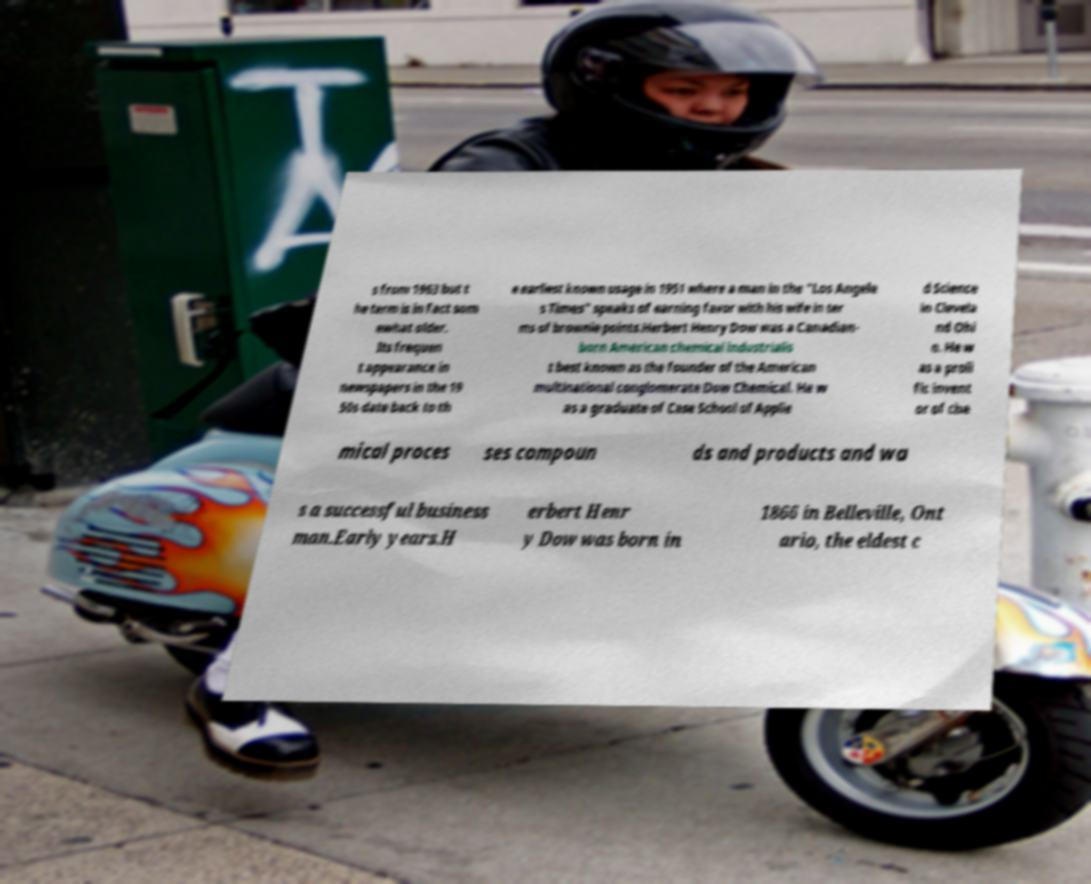Can you accurately transcribe the text from the provided image for me? s from 1963 but t he term is in fact som ewhat older. Its frequen t appearance in newspapers in the 19 50s date back to th e earliest known usage in 1951 where a man in the "Los Angele s Times" speaks of earning favor with his wife in ter ms of brownie points.Herbert Henry Dow was a Canadian- born American chemical industrialis t best known as the founder of the American multinational conglomerate Dow Chemical. He w as a graduate of Case School of Applie d Science in Clevela nd Ohi o. He w as a proli fic invent or of che mical proces ses compoun ds and products and wa s a successful business man.Early years.H erbert Henr y Dow was born in 1866 in Belleville, Ont ario, the eldest c 